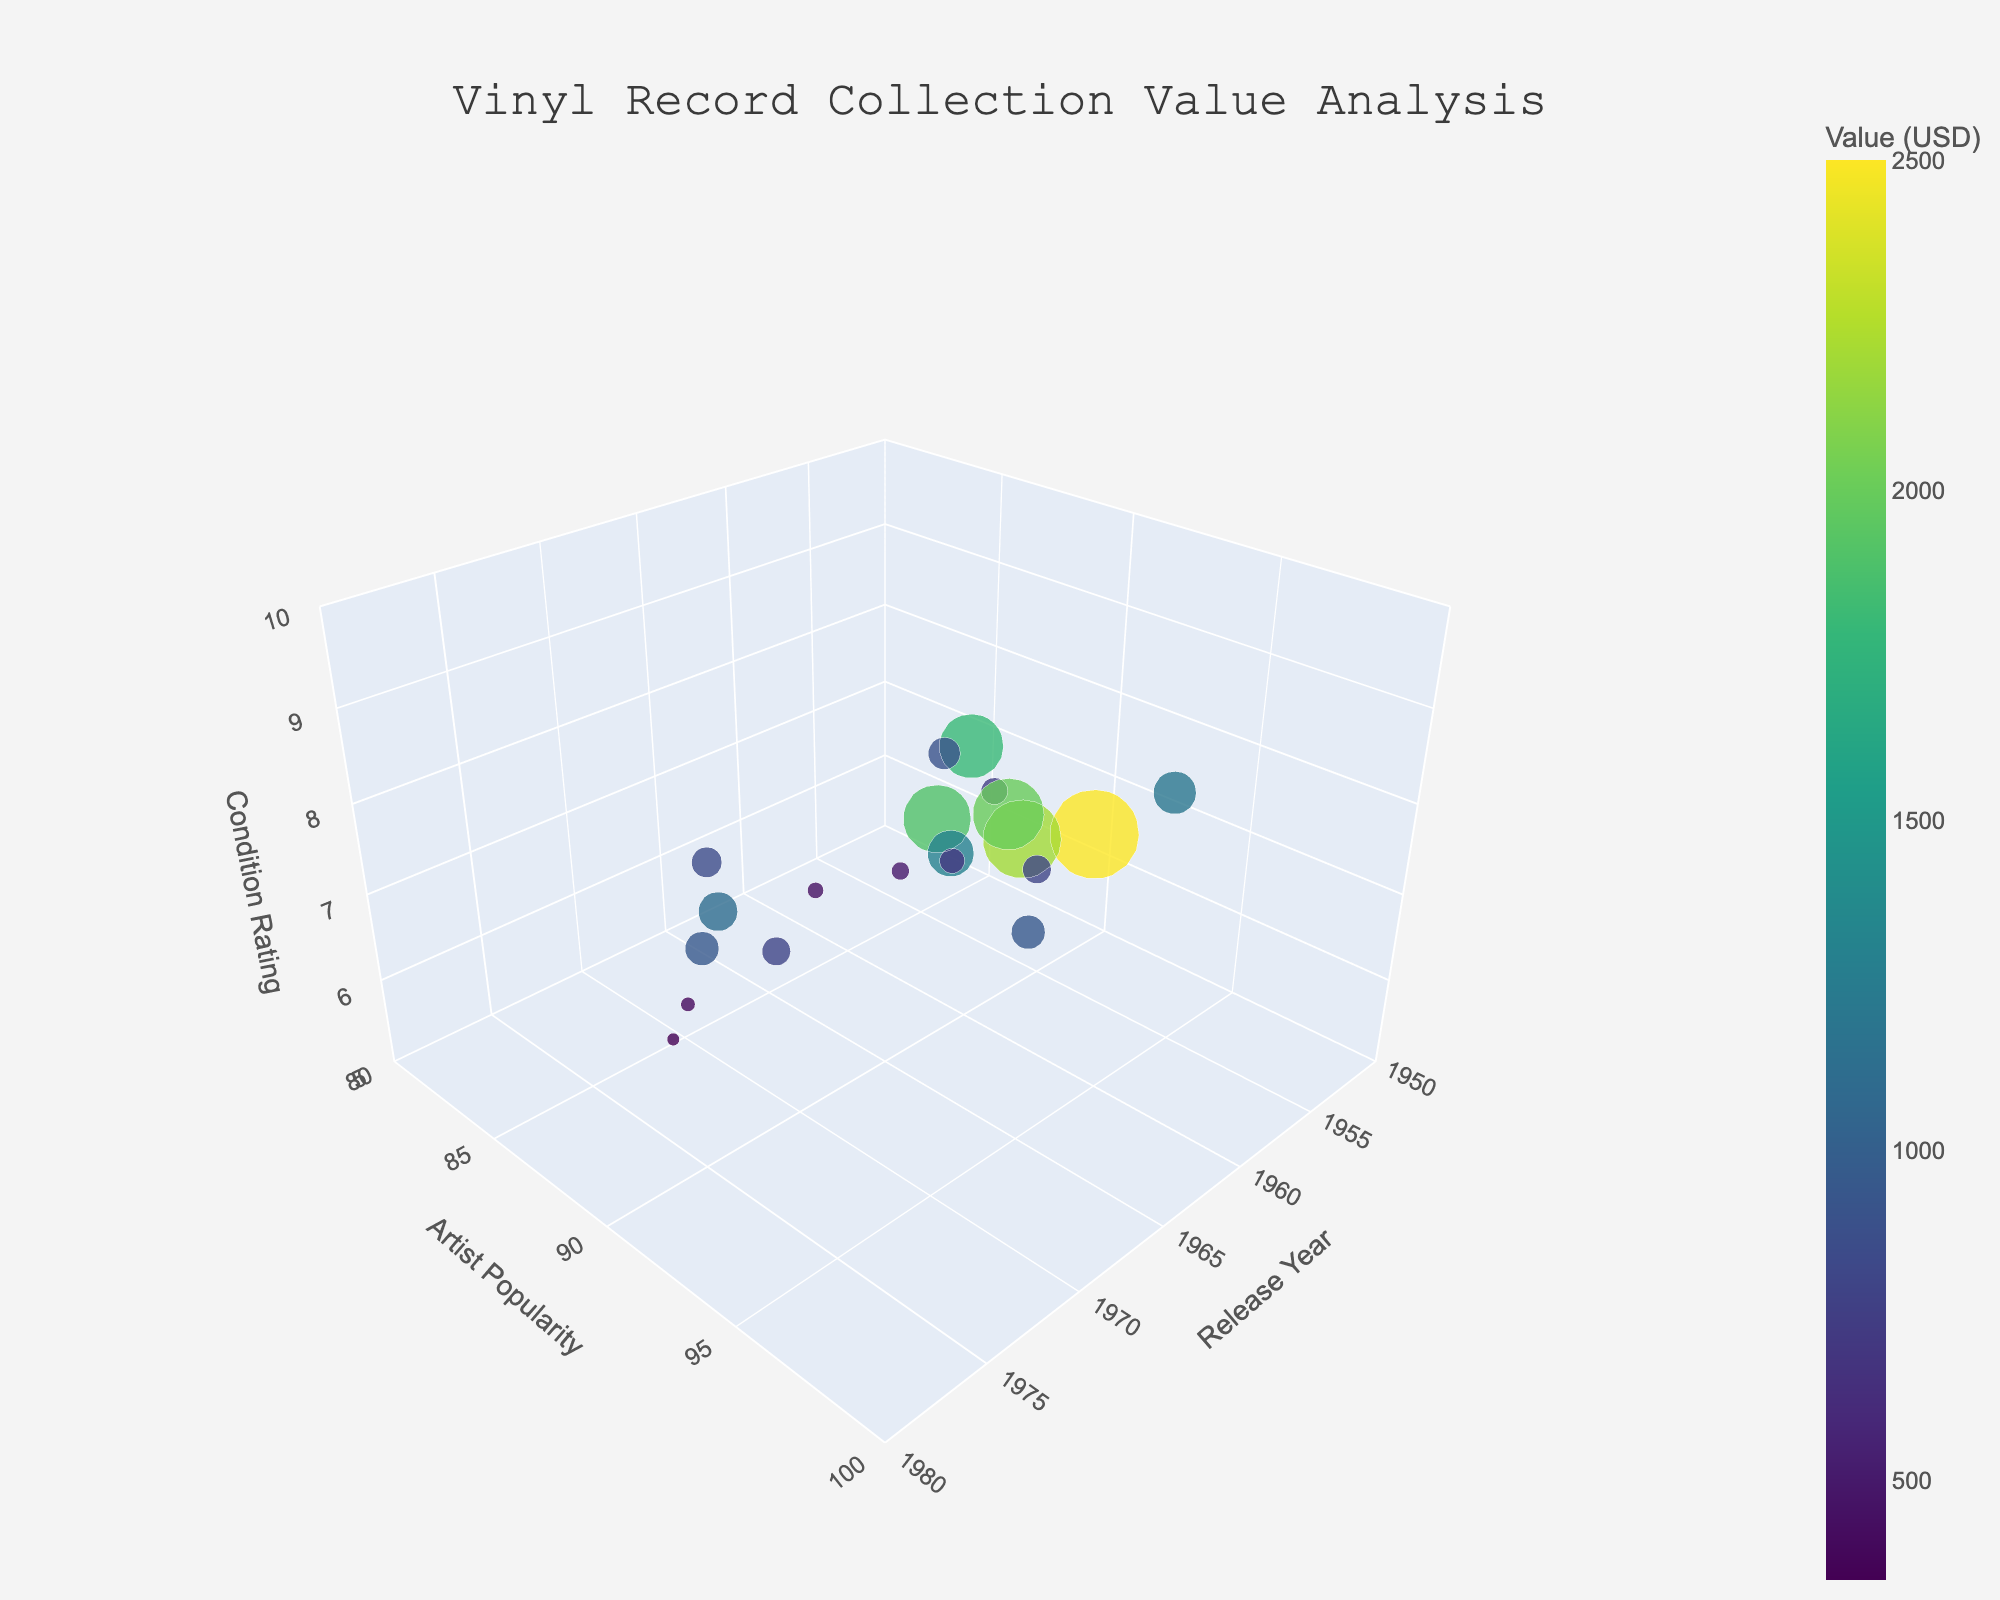What's the title of the plot? The title of the plot is written at the top center of the figure.
Answer: "Vinyl Record Collection Value Analysis" How many data points are there? Each marker in the 3D scatter plot represents a data point. Counting all these markers will give the total number of data points.
Answer: 20 Which record has a higher value: the one released in 1962 with a condition rating of 6, or the one released in 1972 with a condition rating of 6? Look at the specific markers for the years 1962 and 1972 both with condition rating 6 and compare the sizes of these markers.
Answer: 1962 What is the range of artist popularity values in the plot? Observe the y-axis, which represents artist popularity, and note the values at the minimum and maximum ends.
Answer: 85 to 98 Does a higher artist popularity always mean a higher value? Compare the size of the markers along the y-axis, representing artist popularity.
Answer: Not always Which release year has the most records with a condition rating of 9? Count the number of markers that have a z-axis value of 9 for each release year and find the year with the most counts.
Answer: 1969 Are newer records generally in better condition? Look at the trend where markers on the right (newer years) along the x-axis and see if they are higher on the z-axis (condition rating).
Answer: Yes What's the average condition rating for vinyl records released in the 1960s? Identify all markers in the 1960s along the x-axis, note their z-axis values (condition rating), sum them up, and divide by the number of records.
Answer: (8 + 9 + 6 + 9 + 9 + 8 + 7 + 7) / 8 ≈ 7.875 